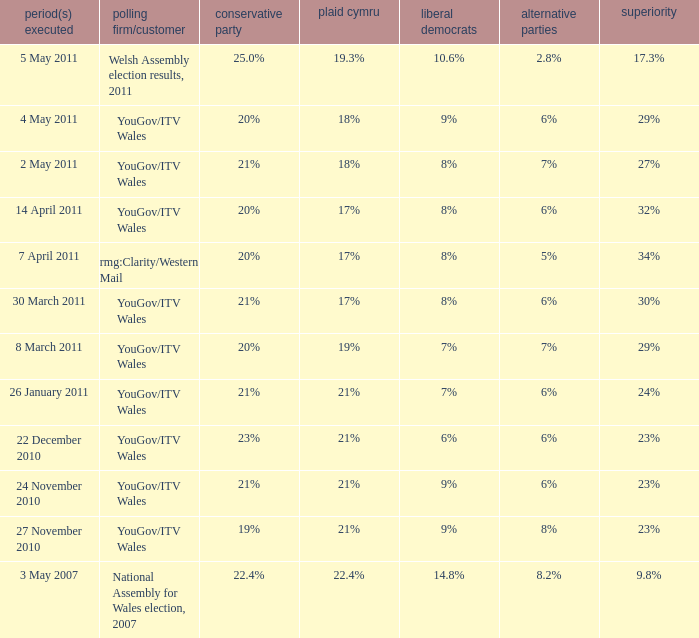Tell me the dates conducted for plaid cymru of 19% 8 March 2011. 